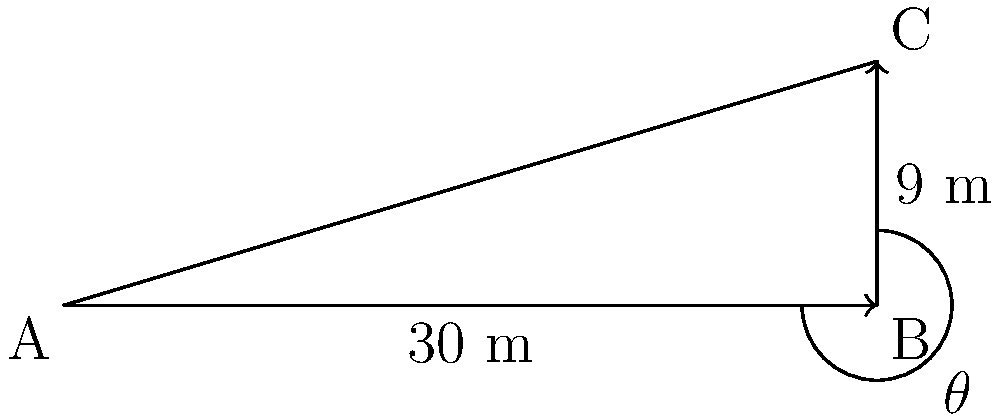A terrace for growing altitude-sensitive medicinal plants needs to be constructed on a hillside. The horizontal distance from the base to the top of the terrace is 30 meters, and the vertical rise is 9 meters. What is the angle of the slope (θ) in degrees for this terrace? To find the angle of the slope, we can use the trigonometric function tangent. The tangent of an angle in a right triangle is the ratio of the opposite side to the adjacent side.

Step 1: Identify the sides of the right triangle
- Opposite side (vertical rise) = 9 meters
- Adjacent side (horizontal distance) = 30 meters

Step 2: Set up the tangent equation
$\tan(\theta) = \frac{\text{opposite}}{\text{adjacent}} = \frac{9}{30}$

Step 3: Simplify the fraction
$\tan(\theta) = \frac{3}{10}$

Step 4: To find θ, we need to use the inverse tangent (arctan or $\tan^{-1}$)
$\theta = \tan^{-1}(\frac{3}{10})$

Step 5: Calculate the angle using a calculator or trigonometric tables
$\theta \approx 16.70^\circ$

Therefore, the angle of the slope for the terrace is approximately 16.70 degrees.
Answer: $16.70^\circ$ 